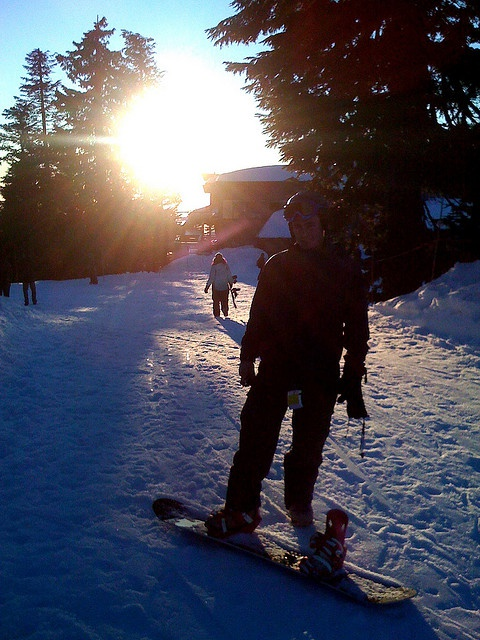Describe the objects in this image and their specific colors. I can see people in lightblue, black, gray, maroon, and navy tones, snowboard in lightblue, black, gray, and navy tones, people in lightblue, purple, maroon, and black tones, people in black, navy, darkblue, and lightblue tones, and people in lightblue, black, navy, and darkblue tones in this image. 